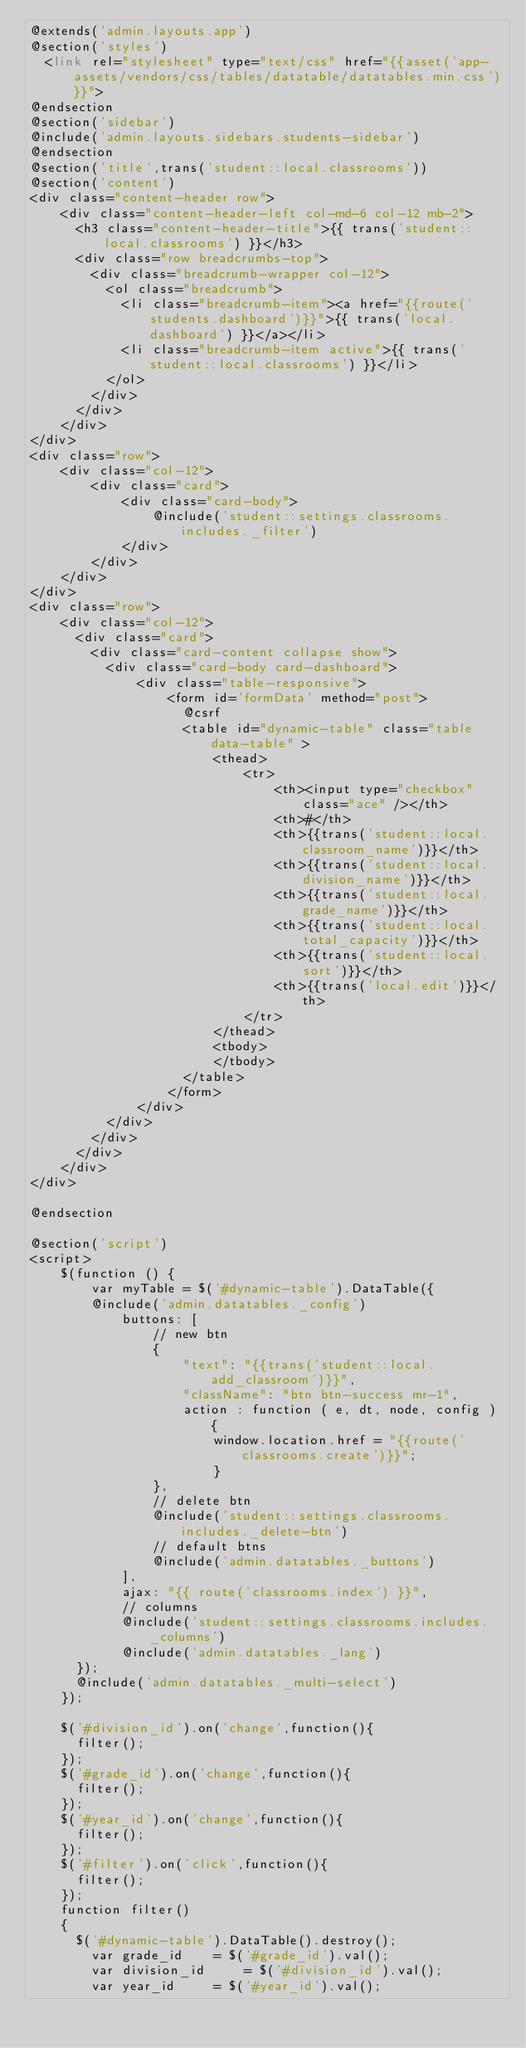<code> <loc_0><loc_0><loc_500><loc_500><_PHP_>@extends('admin.layouts.app')
@section('styles')
  <link rel="stylesheet" type="text/css" href="{{asset('app-assets/vendors/css/tables/datatable/datatables.min.css')}}">
@endsection
@section('sidebar')
@include('admin.layouts.sidebars.students-sidebar')
@endsection
@section('title',trans('student::local.classrooms'))
@section('content')
<div class="content-header row">
    <div class="content-header-left col-md-6 col-12 mb-2">
      <h3 class="content-header-title">{{ trans('student::local.classrooms') }}</h3>
      <div class="row breadcrumbs-top">
        <div class="breadcrumb-wrapper col-12">
          <ol class="breadcrumb">
            <li class="breadcrumb-item"><a href="{{route('students.dashboard')}}">{{ trans('local.dashboard') }}</a></li>
            <li class="breadcrumb-item active">{{ trans('student::local.classrooms') }}</li>
          </ol>
        </div>
      </div>
    </div>
</div>
<div class="row">
    <div class="col-12">
        <div class="card">
            <div class="card-body">
                @include('student::settings.classrooms.includes._filter')
            </div>
        </div>
    </div>
</div>
<div class="row">
    <div class="col-12">
      <div class="card">
        <div class="card-content collapse show">
          <div class="card-body card-dashboard">
              <div class="table-responsive">
                  <form id='formData' method="post">
                    @csrf
                    <table id="dynamic-table" class="table data-table" >
                        <thead>
                            <tr>
                                <th><input type="checkbox" class="ace" /></th>
                                <th>#</th>
                                <th>{{trans('student::local.classroom_name')}}</th>
                                <th>{{trans('student::local.division_name')}}</th>
                                <th>{{trans('student::local.grade_name')}}</th>
                                <th>{{trans('student::local.total_capacity')}}</th>
                                <th>{{trans('student::local.sort')}}</th>
                                <th>{{trans('local.edit')}}</th>
                            </tr>
                        </thead>
                        <tbody>
                        </tbody>
                    </table>
                  </form>
              </div>
          </div>
        </div>
      </div>
    </div>
</div>

@endsection

@section('script')
<script>
    $(function () {
        var myTable = $('#dynamic-table').DataTable({
        @include('admin.datatables._config')
            buttons: [
                // new btn
                {
                    "text": "{{trans('student::local.add_classroom')}}",
                    "className": "btn btn-success mr-1",
                    action : function ( e, dt, node, config ) {
                        window.location.href = "{{route('classrooms.create')}}";
                        }
                },
                // delete btn
                @include('student::settings.classrooms.includes._delete-btn')
                // default btns
                @include('admin.datatables._buttons')
            ],
            ajax: "{{ route('classrooms.index') }}",
            // columns
            @include('student::settings.classrooms.includes._columns')
            @include('admin.datatables._lang')
      });
      @include('admin.datatables._multi-select')
    });

    $('#division_id').on('change',function(){
      filter();
    });
    $('#grade_id').on('change',function(){
      filter();
    });
    $('#year_id').on('change',function(){
      filter();
    });
    $('#filter').on('click',function(){
      filter();
    });
    function filter()
    {
      $('#dynamic-table').DataTable().destroy();
        var grade_id 		= $('#grade_id').val();
        var division_id     = $('#division_id').val();
        var year_id 		= $('#year_id').val();
</code> 